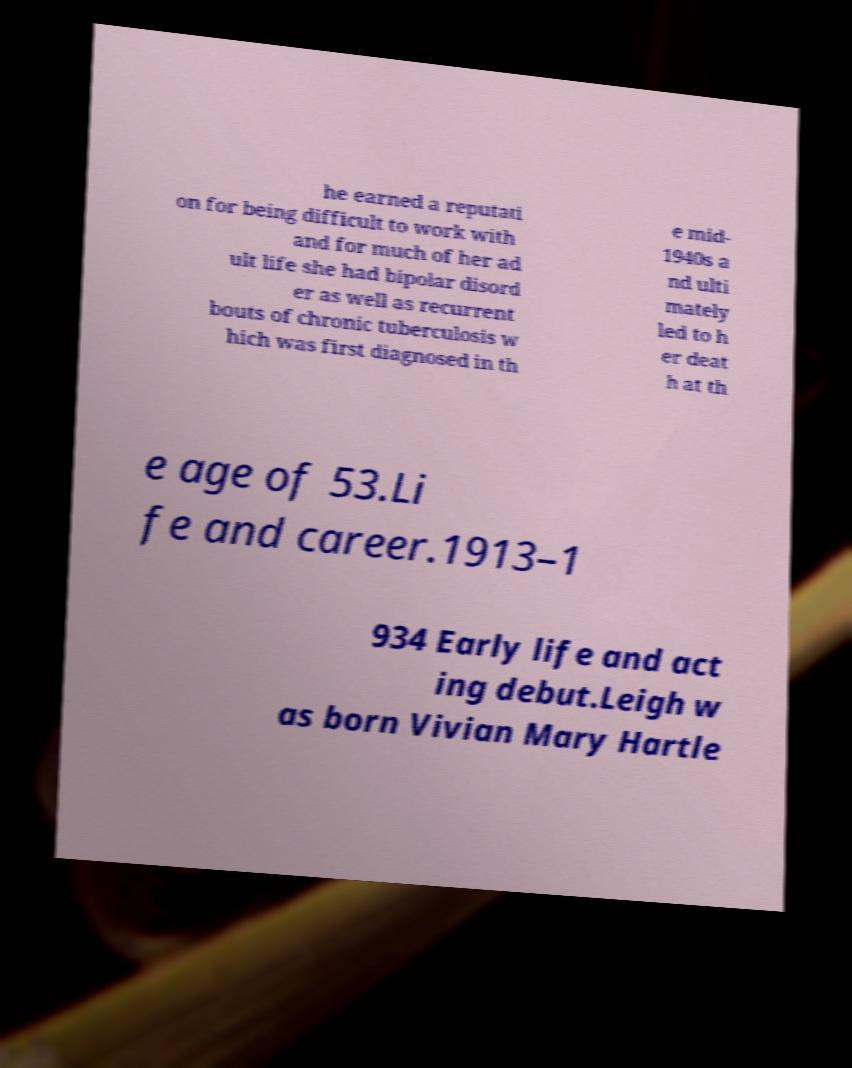For documentation purposes, I need the text within this image transcribed. Could you provide that? he earned a reputati on for being difficult to work with and for much of her ad ult life she had bipolar disord er as well as recurrent bouts of chronic tuberculosis w hich was first diagnosed in th e mid- 1940s a nd ulti mately led to h er deat h at th e age of 53.Li fe and career.1913–1 934 Early life and act ing debut.Leigh w as born Vivian Mary Hartle 